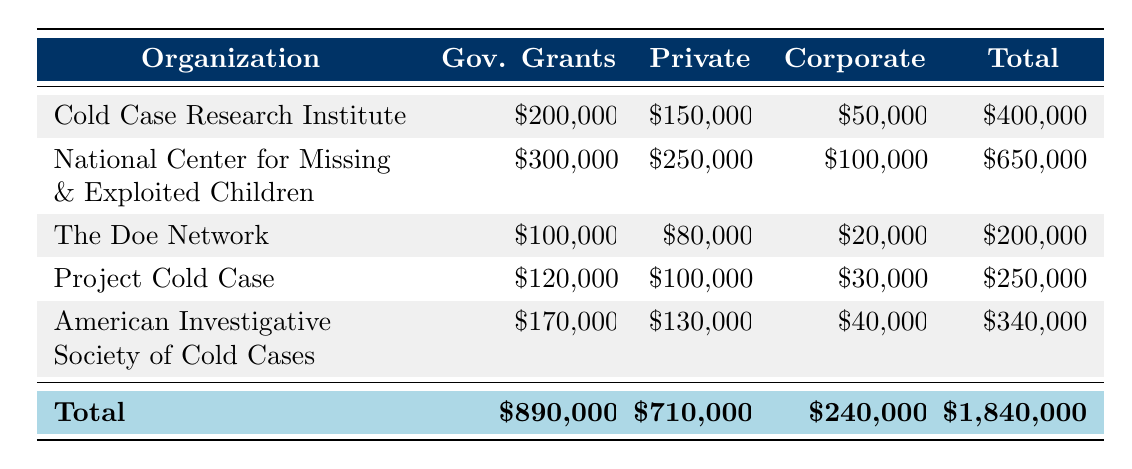What is the total funding received by the National Center for Missing & Exploited Children? The total funding for the National Center for Missing & Exploited Children can be obtained by adding the amounts from each source: Government Grants ($300,000) + Private Donations ($250,000) + Corporate Sponsorships ($100,000) = $650,000.
Answer: $650,000 Which organization received the least amount of funding in total? By reviewing the total funding for each organization, The Doe Network received a total of $200,000, which is the least among all listed organizations.
Answer: The Doe Network How much more did the Cold Case Research Institute receive from Government Grants compared to Corporate Sponsorships? The Cold Case Research Institute received $200,000 from Government Grants and $50,000 from Corporate Sponsorships. The difference is calculated as $200,000 - $50,000 = $150,000.
Answer: $150,000 Is the total funding received by the American Investigative Society of Cold Cases greater than $300,000? The total funding for the American Investigative Society of Cold Cases is $340,000, which is indeed greater than $300,000.
Answer: Yes What is the average amount of funding received from Corporate Sponsorships across all organizations? To find the average, first sum the Corporate Sponsorship amounts: $50,000 + $100,000 + $20,000 + $30,000 + $40,000 = $240,000. Then, divide by the number of organizations, which is 5: $240,000 / 5 = $48,000.
Answer: $48,000 What is the total amount received from Government Grants by all organizations combined? To find the total from Government Grants, add up the amounts: $200,000 + $300,000 + $100,000 + $120,000 + $170,000 = $890,000.
Answer: $890,000 Did Project Cold Case receive more funding from Private Donations than The Doe Network? Project Cold Case received $100,000 from Private Donations, and The Doe Network received $80,000. Since $100,000 is greater than $80,000, Project Cold Case did receive more.
Answer: Yes Which organization receives the most funding from Corporate Sponsorships? Reviewing the Corporate Sponsorship values, the National Center for Missing & Exploited Children received $100,000, which is more than any other organization's Corporate Sponsorship amount.
Answer: National Center for Missing & Exploited Children 